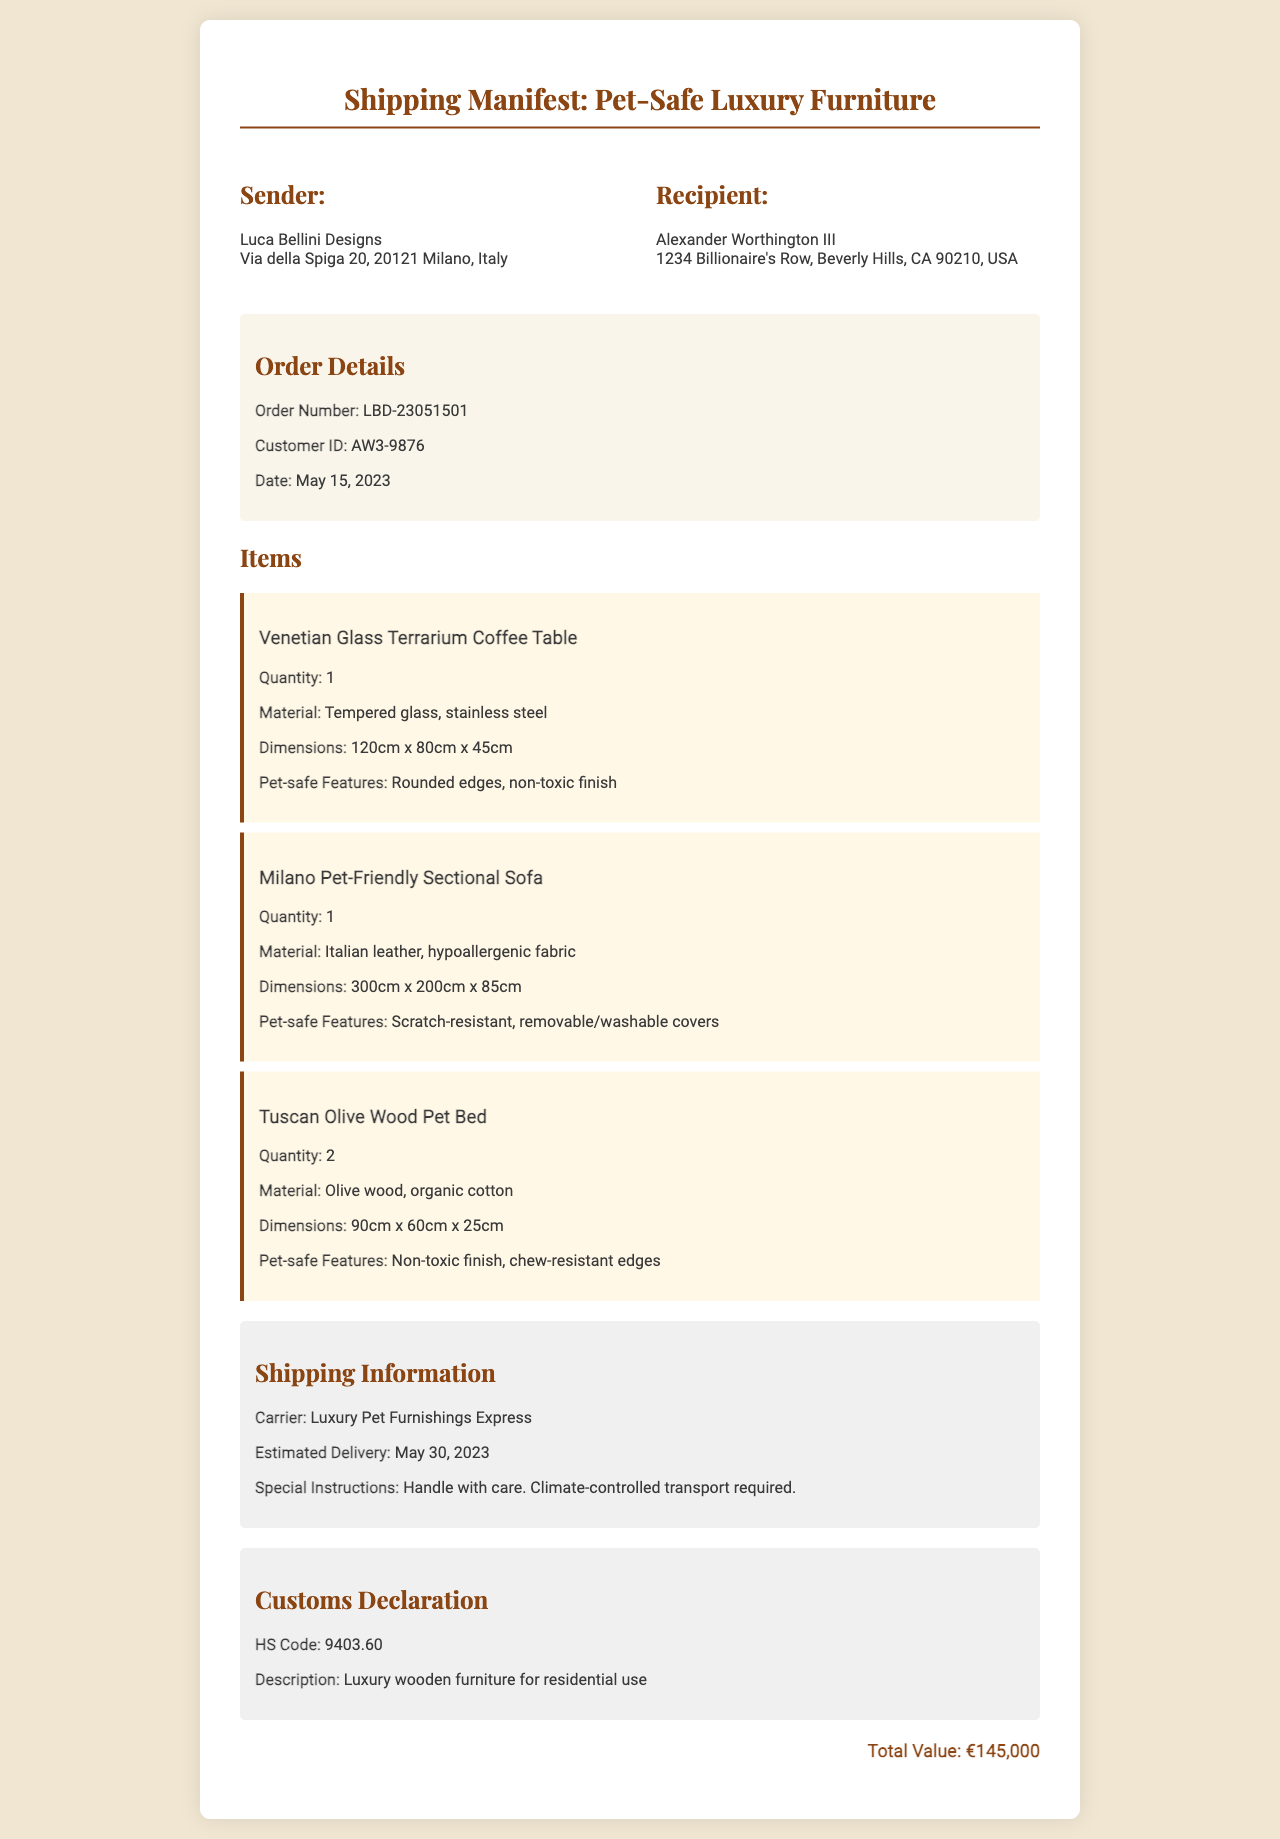What is the sender's name? The sender's name is indicated at the top of the document in the sender's section.
Answer: Luca Bellini Designs What is the recipient's address? The recipient's address is found in the recipient's section of the document.
Answer: 1234 Billionaire's Row, Beverly Hills, CA 90210, USA What is the estimated delivery date? The estimated delivery date is stated in the shipping information section of the document.
Answer: May 30, 2023 How many Tuscan Olive Wood Pet Beds are included? The quantity of the Tuscan Olive Wood Pet Beds is listed in the items section.
Answer: 2 What material is used for the Milano Pet-Friendly Sectional Sofa? The material is specified in the item's description for the sectional sofa.
Answer: Italian leather, hypoallergenic fabric What are the pet-safe features of the Venetian Glass Terrarium Coffee Table? The pet-safe features are mentioned in the item's details.
Answer: Rounded edges, non-toxic finish What is the total value of the order? The total value of the order is given at the bottom of the document.
Answer: €145,000 What is the HS Code provided in the customs declaration? The HS Code is found in the customs declaration section of the document.
Answer: 9403.60 